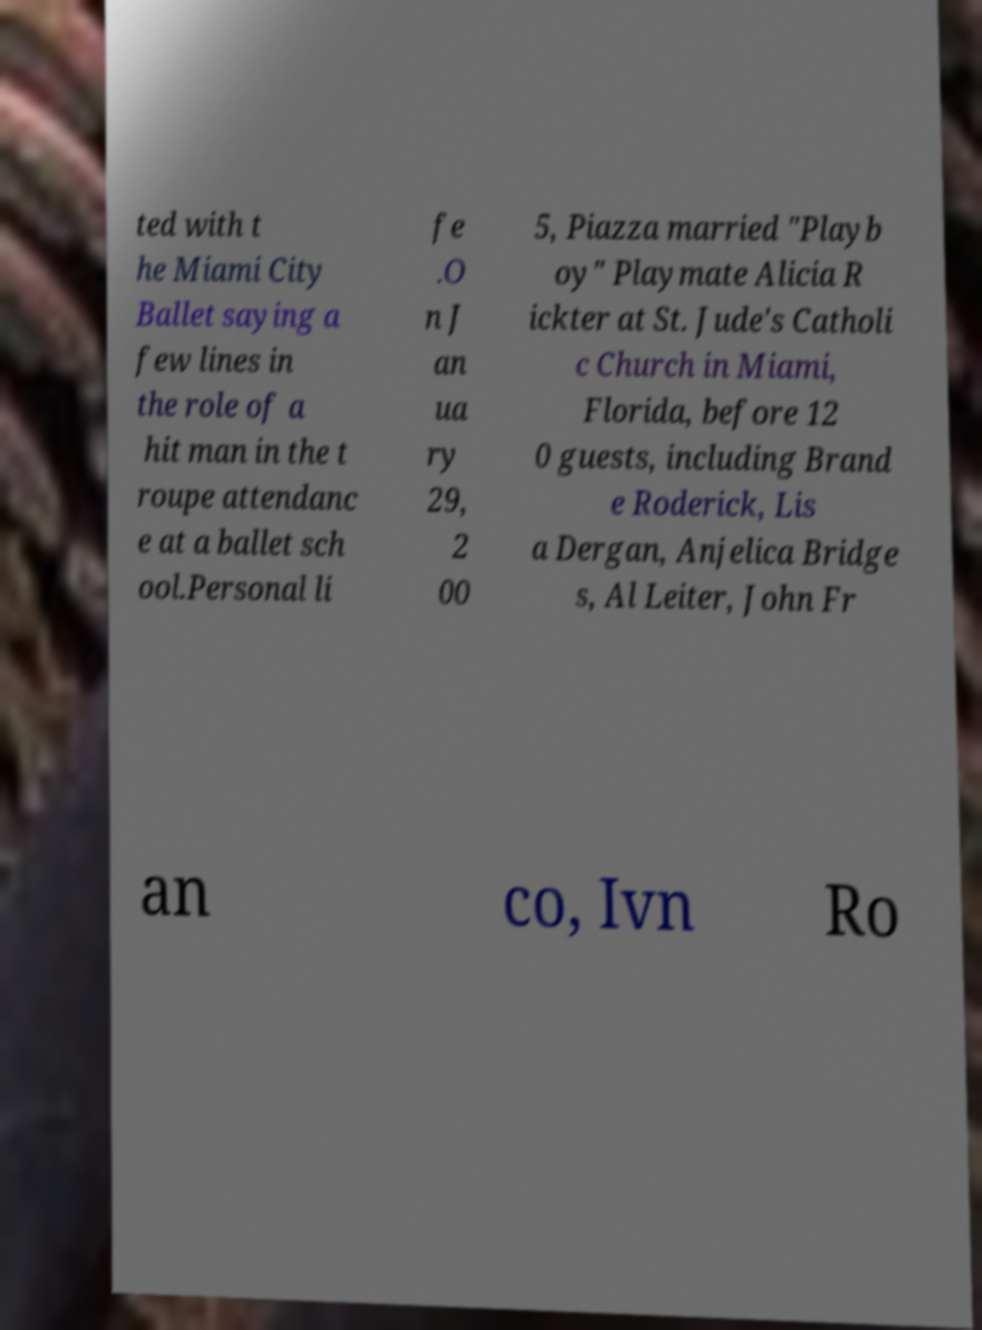There's text embedded in this image that I need extracted. Can you transcribe it verbatim? ted with t he Miami City Ballet saying a few lines in the role of a hit man in the t roupe attendanc e at a ballet sch ool.Personal li fe .O n J an ua ry 29, 2 00 5, Piazza married "Playb oy" Playmate Alicia R ickter at St. Jude's Catholi c Church in Miami, Florida, before 12 0 guests, including Brand e Roderick, Lis a Dergan, Anjelica Bridge s, Al Leiter, John Fr an co, Ivn Ro 